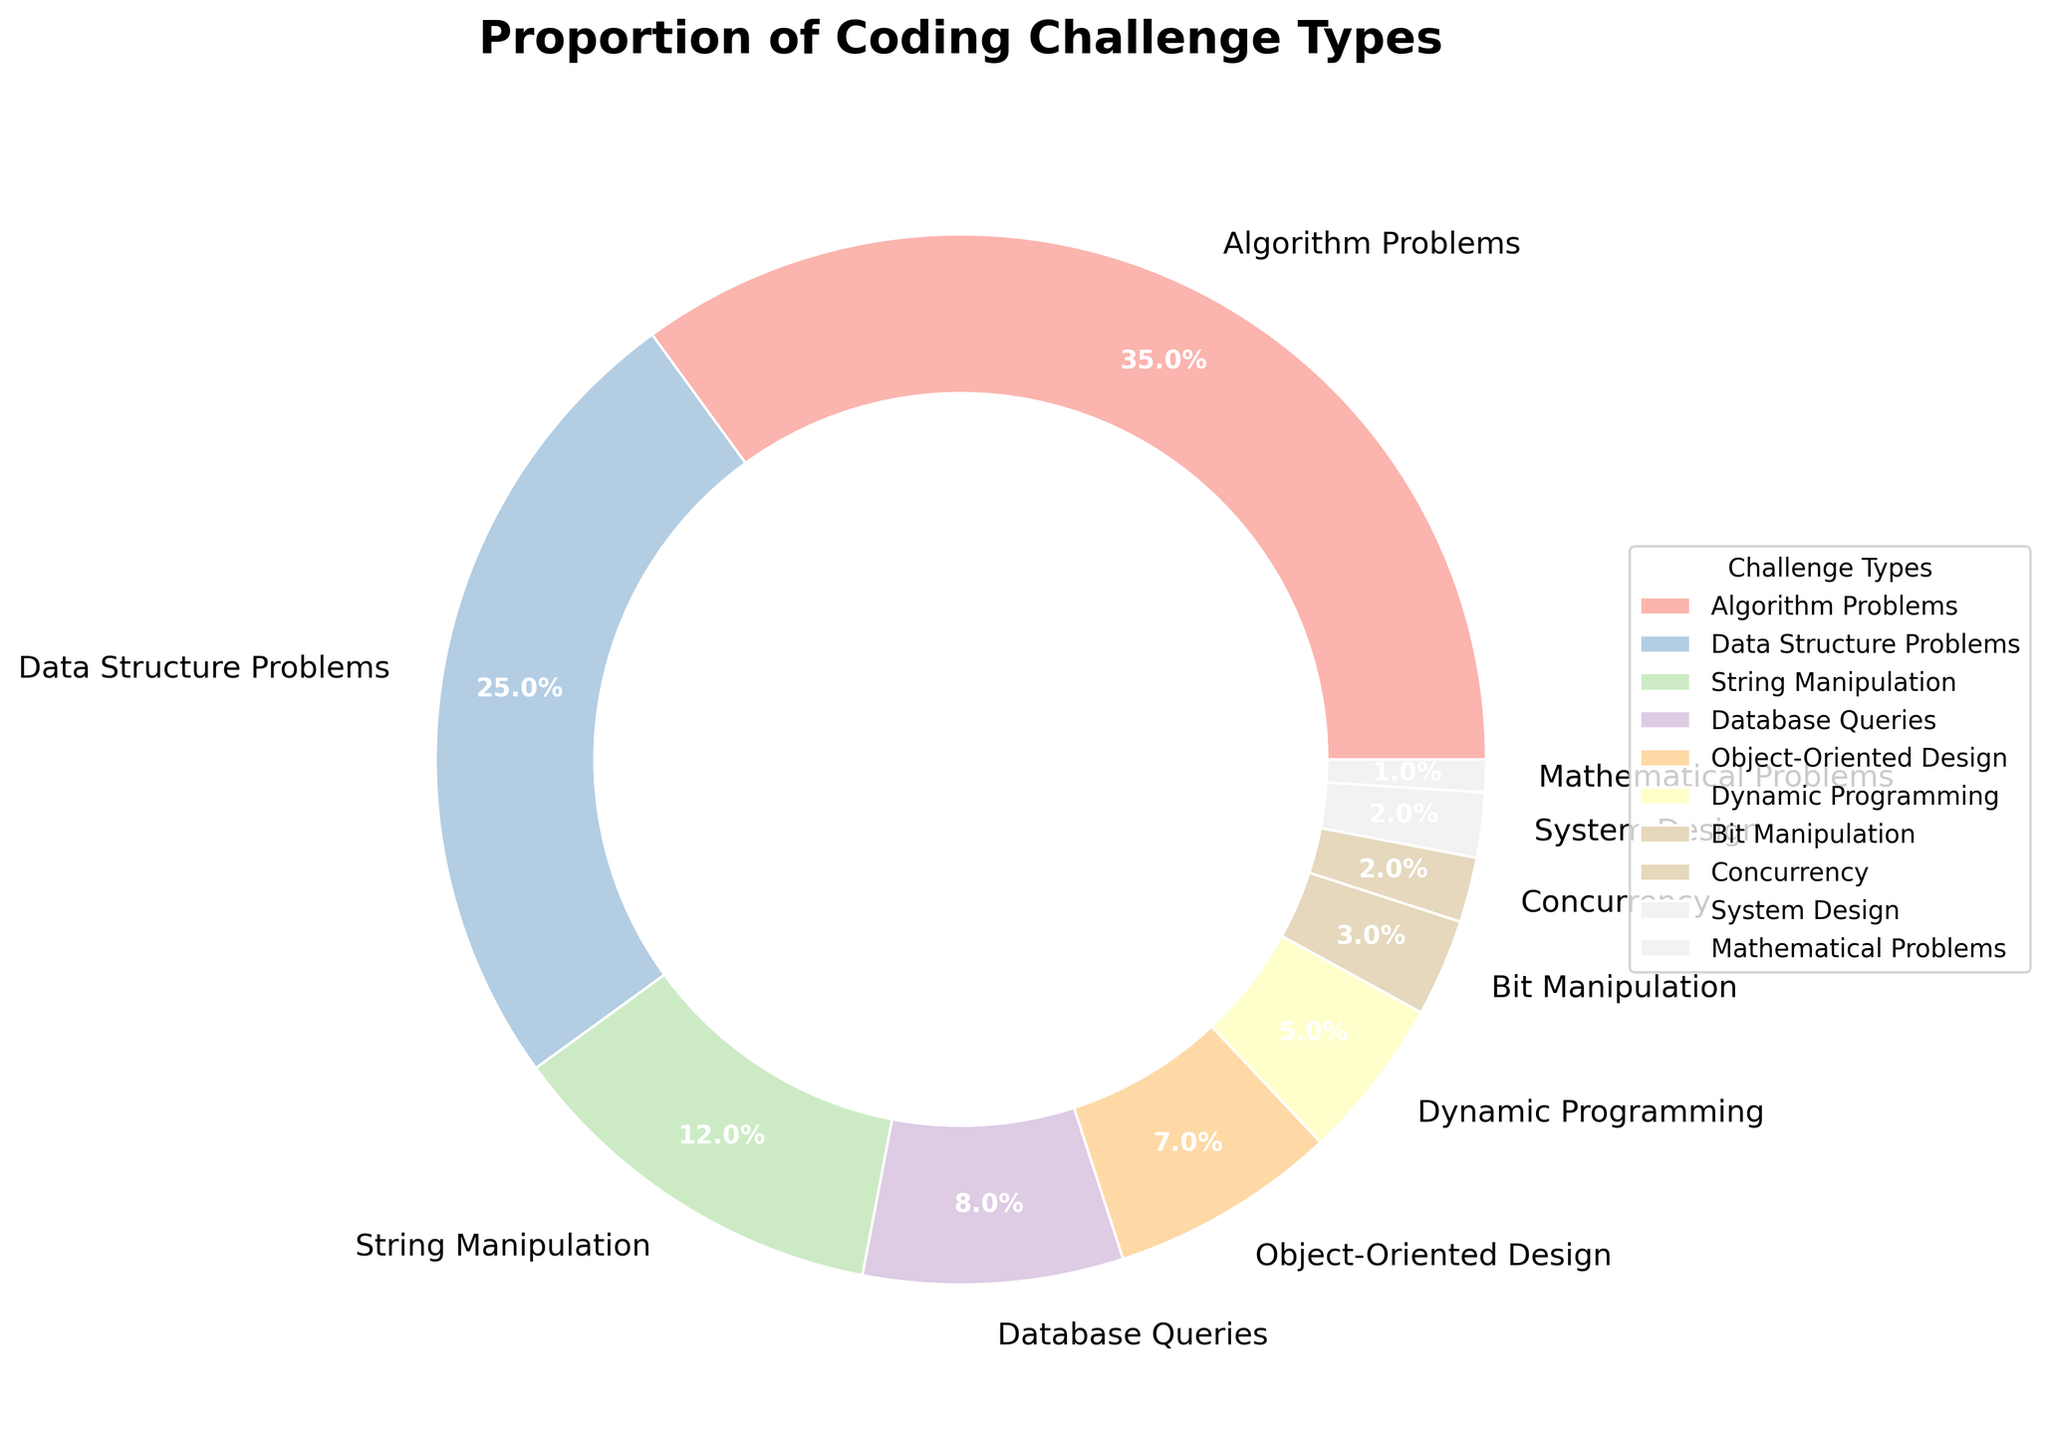Which type of coding challenge has the largest proportion? The pie chart shows that Algorithm Problems occupy the largest slice of the chart. The label indicating "Algorithm Problems" is associated with 35%, which is the highest percentage among all categories.
Answer: Algorithm Problems Which types of coding challenges combined make up exactly half of the total proportion? The two types are Algorithm Problems and Data Structure Problems. Algorithm Problems are 35% and Data Structure Problems are 25%. Their combined total is 35% + 25% = 60%, which exceeds half. Considering the next possible sets, the closest without exceeding half is Algorithm Problems (35%) and String Manipulation (12%), combined is 35% + 12% = 47%, less half. Therefore, including the second highest, which is Data Structure Problems, gives the exact half (35% + 25%)
Answer: Algorithm Problems and Data Structure Problems Which three types of challenges together make up more than 60%? Algorithm Problems (35%), Data Structure Problems (25%), and String Manipulation (12%) together sum up to 35% + 25% + 12% = 72%, which is more than 60%.
Answer: Algorithm Problems, Data Structure Problems, String Manipulation What is the smallest proportion of coding challenge types? The smallest slice of the pie chart is labeled "Mathematical Problems" with 1%.
Answer: Mathematical Problems Which coding challenge types are under 10%? The segments for Database Queries (8%), Object-Oriented Design (7%), Dynamic Programming (5%), Bit Manipulation (3%), Concurrency (2%), System Design (2%), and Mathematical Problems (1%) are all under 10%.
Answer: Database Queries, Object-Oriented Design, Dynamic Programming, Bit Manipulation, Concurrency, System Design, Mathematical Problems Which has a higher proportion, Database Queries or Object-Oriented Design? The pie chart segments for Database Queries and Object-Oriented Design are compared. Database Queries have 8%, and Object-Oriented Design has 7%. Therefore, Database Queries have a higher proportion.
Answer: Database Queries How much larger is Algorithm Problems compared to Mathematical Problems? To find the difference in their proportions: Algorithm Problems is 35%, and Mathematical Problems is 1%. The difference is 35% - 1% = 34%.
Answer: 34% What is the collective proportion of Dynamic Programming, Bit Manipulation, Concurrency, and System Design challenges? Adding these proportions together: Dynamic Programming (5%), Bit Manipulation (3%), Concurrency (2%), System Design (2%) gives 5% + 3% + 2% + 2% = 12%.
Answer: 12% Calculate the proportion for all types except Algorithm Problems and Data Structure Problems. All challenge types except Algorithm Problems (35%) and Data Structure Problems (25%) sum to 100% - (35% + 25%) = 40%.
Answer: 40% What color is used to represent the Object-Oriented Design challenge? Looking at the pie chart, the wedge corresponding to Object-Oriented Design is colored with a light pastel hue as per the Pastel1 colormap used. In the absence of color names, the exact hue may be identified directly from the chart.
Answer: Light pastel (pastel hues depend on colormap details) 